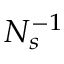<formula> <loc_0><loc_0><loc_500><loc_500>N _ { s } ^ { - 1 }</formula> 